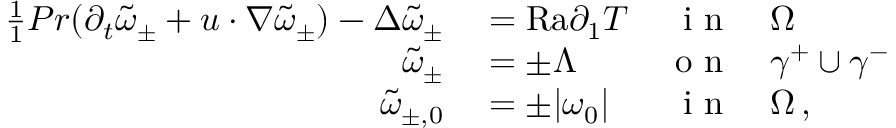<formula> <loc_0><loc_0><loc_500><loc_500>\begin{array} { r l r l } { \frac { 1 } { 1 } { P r } ( \partial _ { t } \tilde { \omega } _ { \pm } + u \cdot \nabla \tilde { \omega } _ { \pm } ) - \Delta \tilde { \omega } _ { \pm } } & = { R a } \partial _ { 1 } T } & { i n } & \Omega } \\ { \tilde { \omega } _ { \pm } } & = \pm \Lambda } & { o n } & \gamma ^ { + } \cup \gamma ^ { - } } \\ { \tilde { \omega } _ { \pm , 0 } } & = \pm | \omega _ { 0 } | } & { i n } & \Omega \, , } \end{array}</formula> 